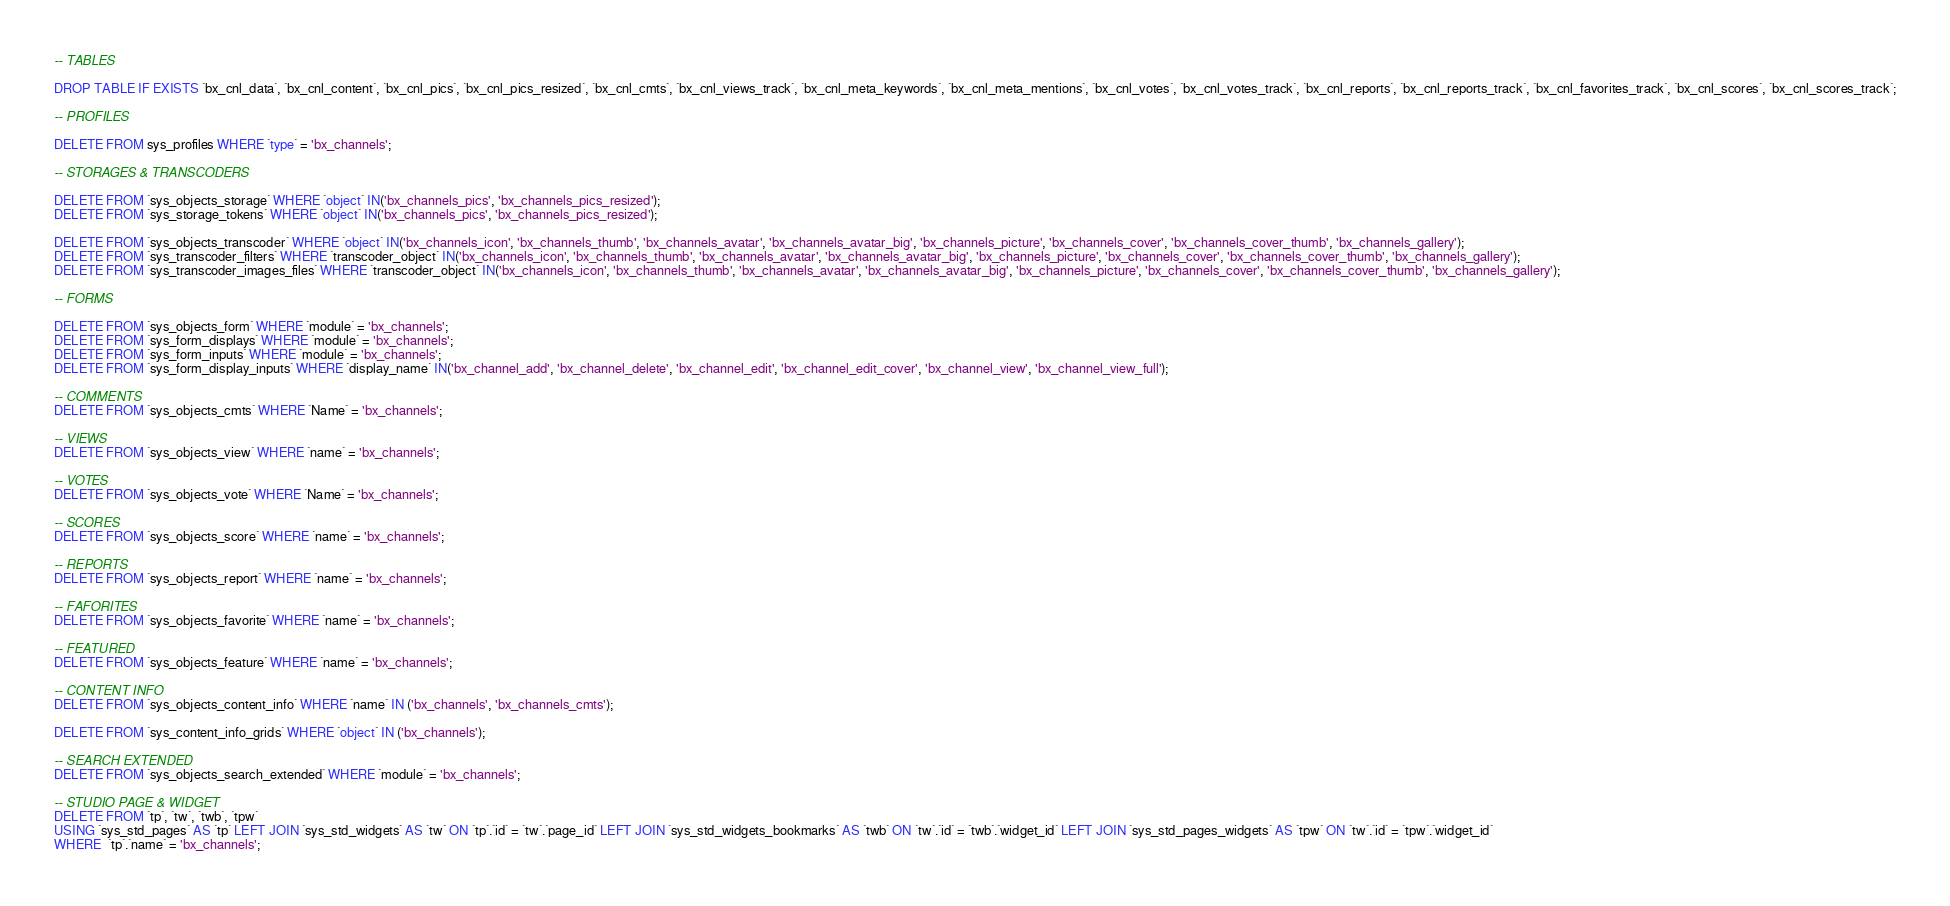Convert code to text. <code><loc_0><loc_0><loc_500><loc_500><_SQL_>
-- TABLES

DROP TABLE IF EXISTS `bx_cnl_data`, `bx_cnl_content`, `bx_cnl_pics`, `bx_cnl_pics_resized`, `bx_cnl_cmts`, `bx_cnl_views_track`, `bx_cnl_meta_keywords`, `bx_cnl_meta_mentions`, `bx_cnl_votes`, `bx_cnl_votes_track`, `bx_cnl_reports`, `bx_cnl_reports_track`, `bx_cnl_favorites_track`, `bx_cnl_scores`, `bx_cnl_scores_track`;

-- PROFILES

DELETE FROM sys_profiles WHERE `type` = 'bx_channels';

-- STORAGES & TRANSCODERS

DELETE FROM `sys_objects_storage` WHERE `object` IN('bx_channels_pics', 'bx_channels_pics_resized');
DELETE FROM `sys_storage_tokens` WHERE `object` IN('bx_channels_pics', 'bx_channels_pics_resized');

DELETE FROM `sys_objects_transcoder` WHERE `object` IN('bx_channels_icon', 'bx_channels_thumb', 'bx_channels_avatar', 'bx_channels_avatar_big', 'bx_channels_picture', 'bx_channels_cover', 'bx_channels_cover_thumb', 'bx_channels_gallery');
DELETE FROM `sys_transcoder_filters` WHERE `transcoder_object` IN('bx_channels_icon', 'bx_channels_thumb', 'bx_channels_avatar', 'bx_channels_avatar_big', 'bx_channels_picture', 'bx_channels_cover', 'bx_channels_cover_thumb', 'bx_channels_gallery');
DELETE FROM `sys_transcoder_images_files` WHERE `transcoder_object` IN('bx_channels_icon', 'bx_channels_thumb', 'bx_channels_avatar', 'bx_channels_avatar_big', 'bx_channels_picture', 'bx_channels_cover', 'bx_channels_cover_thumb', 'bx_channels_gallery');

-- FORMS

DELETE FROM `sys_objects_form` WHERE `module` = 'bx_channels';
DELETE FROM `sys_form_displays` WHERE `module` = 'bx_channels';
DELETE FROM `sys_form_inputs` WHERE `module` = 'bx_channels';
DELETE FROM `sys_form_display_inputs` WHERE `display_name` IN('bx_channel_add', 'bx_channel_delete', 'bx_channel_edit', 'bx_channel_edit_cover', 'bx_channel_view', 'bx_channel_view_full');

-- COMMENTS
DELETE FROM `sys_objects_cmts` WHERE `Name` = 'bx_channels';

-- VIEWS
DELETE FROM `sys_objects_view` WHERE `name` = 'bx_channels';

-- VOTES
DELETE FROM `sys_objects_vote` WHERE `Name` = 'bx_channels';

-- SCORES
DELETE FROM `sys_objects_score` WHERE `name` = 'bx_channels';

-- REPORTS
DELETE FROM `sys_objects_report` WHERE `name` = 'bx_channels';

-- FAFORITES
DELETE FROM `sys_objects_favorite` WHERE `name` = 'bx_channels';

-- FEATURED
DELETE FROM `sys_objects_feature` WHERE `name` = 'bx_channels';

-- CONTENT INFO
DELETE FROM `sys_objects_content_info` WHERE `name` IN ('bx_channels', 'bx_channels_cmts');

DELETE FROM `sys_content_info_grids` WHERE `object` IN ('bx_channels');

-- SEARCH EXTENDED
DELETE FROM `sys_objects_search_extended` WHERE `module` = 'bx_channels';

-- STUDIO PAGE & WIDGET
DELETE FROM `tp`, `tw`, `twb`, `tpw` 
USING `sys_std_pages` AS `tp` LEFT JOIN `sys_std_widgets` AS `tw` ON `tp`.`id` = `tw`.`page_id` LEFT JOIN `sys_std_widgets_bookmarks` AS `twb` ON `tw`.`id` = `twb`.`widget_id` LEFT JOIN `sys_std_pages_widgets` AS `tpw` ON `tw`.`id` = `tpw`.`widget_id`
WHERE  `tp`.`name` = 'bx_channels';
</code> 